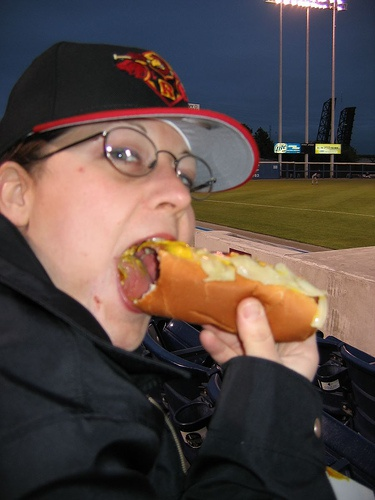Describe the objects in this image and their specific colors. I can see people in black, tan, brown, and gray tones, hot dog in black, brown, orange, and tan tones, chair in black and gray tones, and cup in black and gray tones in this image. 